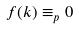Convert formula to latex. <formula><loc_0><loc_0><loc_500><loc_500>f ( k ) \equiv _ { p } 0</formula> 